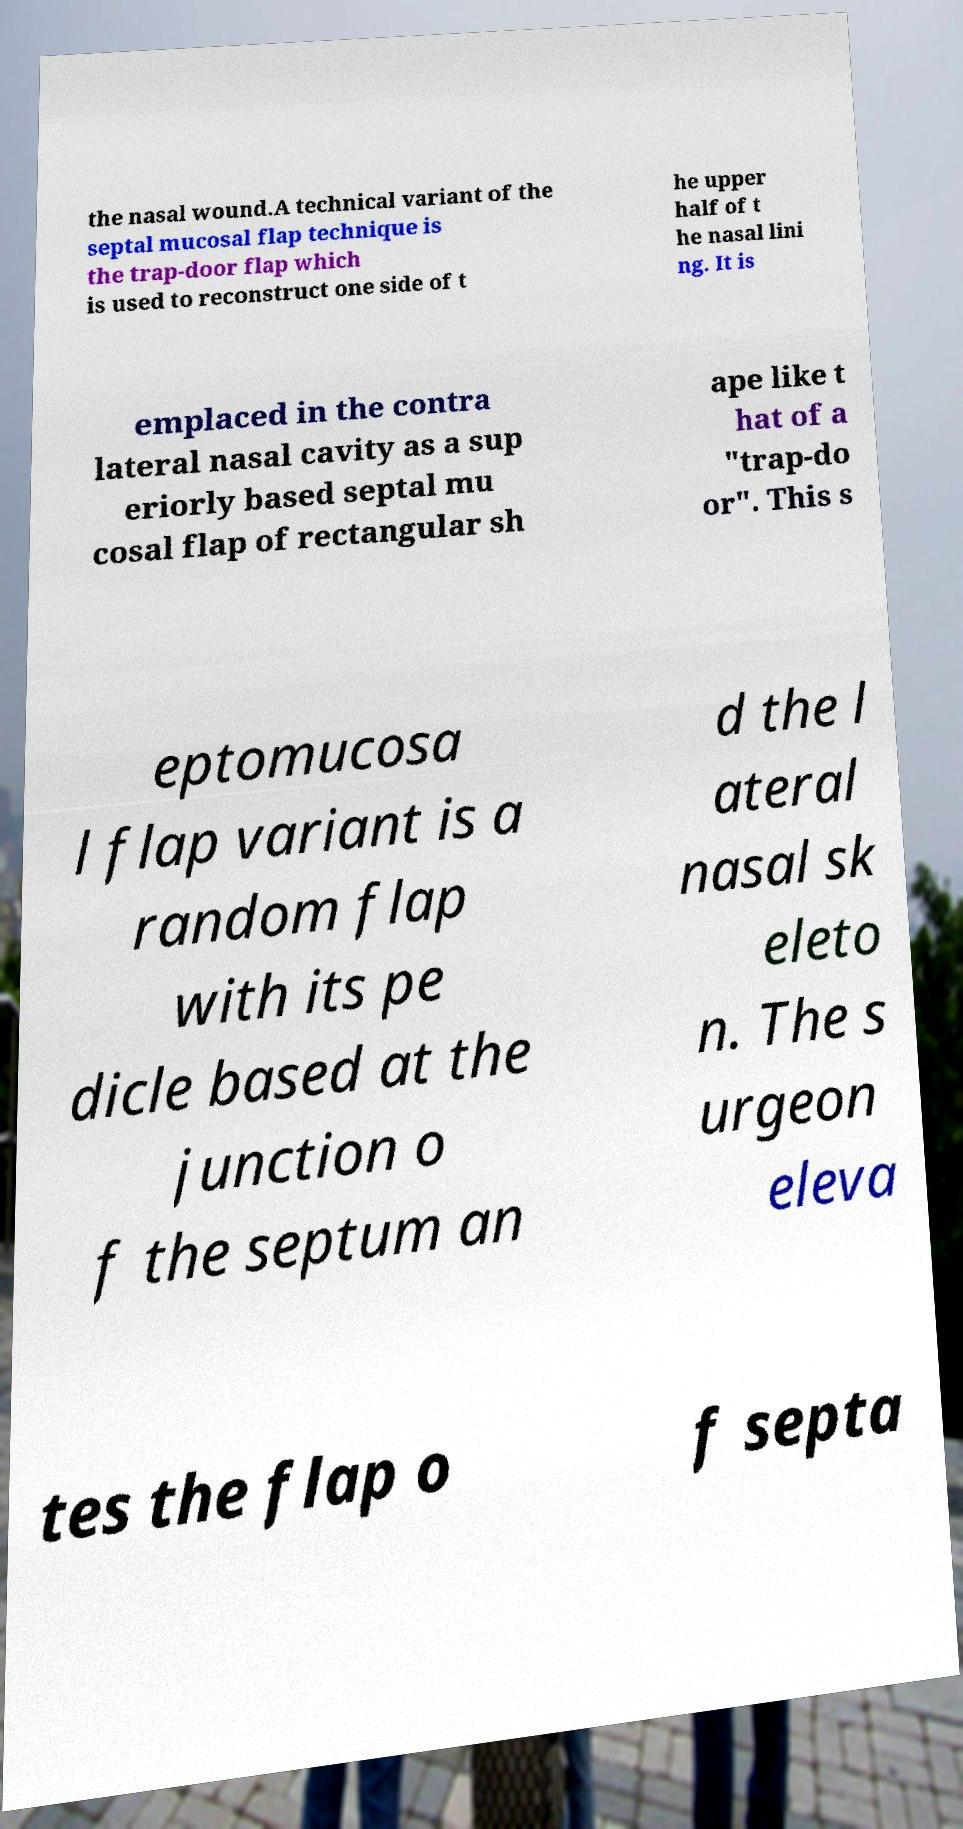Could you extract and type out the text from this image? the nasal wound.A technical variant of the septal mucosal flap technique is the trap-door flap which is used to reconstruct one side of t he upper half of t he nasal lini ng. It is emplaced in the contra lateral nasal cavity as a sup eriorly based septal mu cosal flap of rectangular sh ape like t hat of a "trap-do or". This s eptomucosa l flap variant is a random flap with its pe dicle based at the junction o f the septum an d the l ateral nasal sk eleto n. The s urgeon eleva tes the flap o f septa 